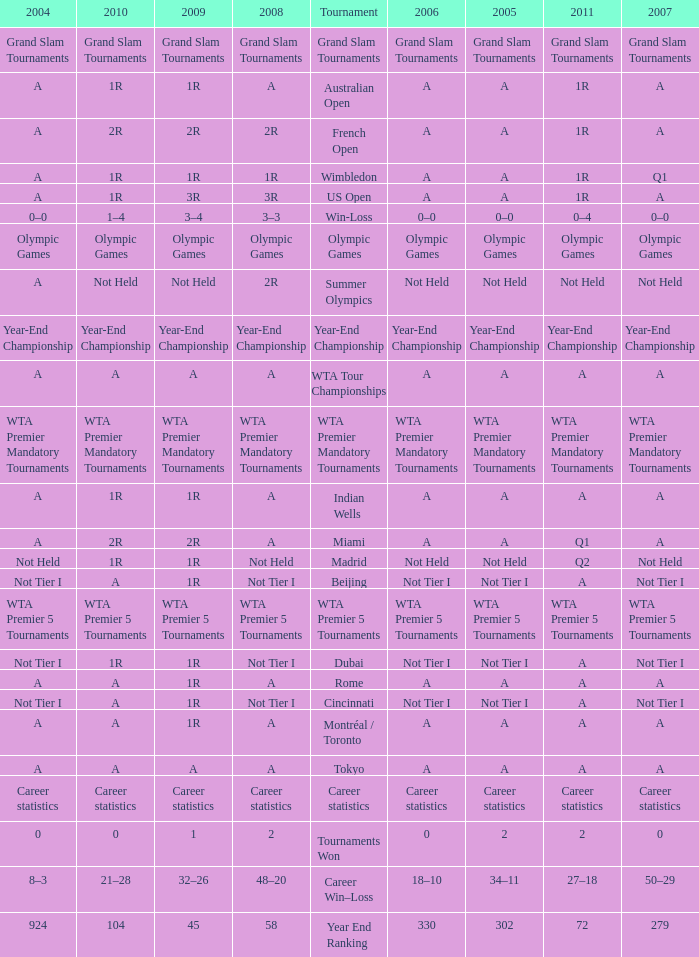Could you help me parse every detail presented in this table? {'header': ['2004', '2010', '2009', '2008', 'Tournament', '2006', '2005', '2011', '2007'], 'rows': [['Grand Slam Tournaments', 'Grand Slam Tournaments', 'Grand Slam Tournaments', 'Grand Slam Tournaments', 'Grand Slam Tournaments', 'Grand Slam Tournaments', 'Grand Slam Tournaments', 'Grand Slam Tournaments', 'Grand Slam Tournaments'], ['A', '1R', '1R', 'A', 'Australian Open', 'A', 'A', '1R', 'A'], ['A', '2R', '2R', '2R', 'French Open', 'A', 'A', '1R', 'A'], ['A', '1R', '1R', '1R', 'Wimbledon', 'A', 'A', '1R', 'Q1'], ['A', '1R', '3R', '3R', 'US Open', 'A', 'A', '1R', 'A'], ['0–0', '1–4', '3–4', '3–3', 'Win-Loss', '0–0', '0–0', '0–4', '0–0'], ['Olympic Games', 'Olympic Games', 'Olympic Games', 'Olympic Games', 'Olympic Games', 'Olympic Games', 'Olympic Games', 'Olympic Games', 'Olympic Games'], ['A', 'Not Held', 'Not Held', '2R', 'Summer Olympics', 'Not Held', 'Not Held', 'Not Held', 'Not Held'], ['Year-End Championship', 'Year-End Championship', 'Year-End Championship', 'Year-End Championship', 'Year-End Championship', 'Year-End Championship', 'Year-End Championship', 'Year-End Championship', 'Year-End Championship'], ['A', 'A', 'A', 'A', 'WTA Tour Championships', 'A', 'A', 'A', 'A'], ['WTA Premier Mandatory Tournaments', 'WTA Premier Mandatory Tournaments', 'WTA Premier Mandatory Tournaments', 'WTA Premier Mandatory Tournaments', 'WTA Premier Mandatory Tournaments', 'WTA Premier Mandatory Tournaments', 'WTA Premier Mandatory Tournaments', 'WTA Premier Mandatory Tournaments', 'WTA Premier Mandatory Tournaments'], ['A', '1R', '1R', 'A', 'Indian Wells', 'A', 'A', 'A', 'A'], ['A', '2R', '2R', 'A', 'Miami', 'A', 'A', 'Q1', 'A'], ['Not Held', '1R', '1R', 'Not Held', 'Madrid', 'Not Held', 'Not Held', 'Q2', 'Not Held'], ['Not Tier I', 'A', '1R', 'Not Tier I', 'Beijing', 'Not Tier I', 'Not Tier I', 'A', 'Not Tier I'], ['WTA Premier 5 Tournaments', 'WTA Premier 5 Tournaments', 'WTA Premier 5 Tournaments', 'WTA Premier 5 Tournaments', 'WTA Premier 5 Tournaments', 'WTA Premier 5 Tournaments', 'WTA Premier 5 Tournaments', 'WTA Premier 5 Tournaments', 'WTA Premier 5 Tournaments'], ['Not Tier I', '1R', '1R', 'Not Tier I', 'Dubai', 'Not Tier I', 'Not Tier I', 'A', 'Not Tier I'], ['A', 'A', '1R', 'A', 'Rome', 'A', 'A', 'A', 'A'], ['Not Tier I', 'A', '1R', 'Not Tier I', 'Cincinnati', 'Not Tier I', 'Not Tier I', 'A', 'Not Tier I'], ['A', 'A', '1R', 'A', 'Montréal / Toronto', 'A', 'A', 'A', 'A'], ['A', 'A', 'A', 'A', 'Tokyo', 'A', 'A', 'A', 'A'], ['Career statistics', 'Career statistics', 'Career statistics', 'Career statistics', 'Career statistics', 'Career statistics', 'Career statistics', 'Career statistics', 'Career statistics'], ['0', '0', '1', '2', 'Tournaments Won', '0', '2', '2', '0'], ['8–3', '21–28', '32–26', '48–20', 'Career Win–Loss', '18–10', '34–11', '27–18', '50–29'], ['924', '104', '45', '58', 'Year End Ranking', '330', '302', '72', '279']]} What is 2011, when 2006 is "A", when 2008 is "A", and when Tournament is "Rome"? A. 